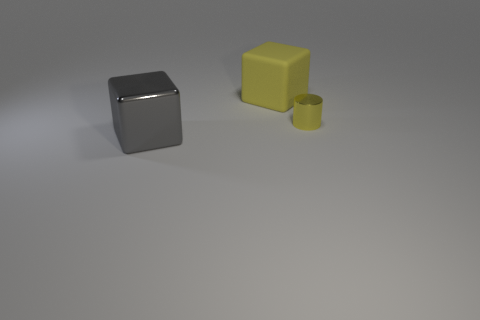Is the number of big blocks in front of the gray shiny object the same as the number of matte cubes that are in front of the yellow shiny object?
Provide a short and direct response. Yes. How many cylinders are the same color as the rubber cube?
Provide a succinct answer. 1. What is the material of the small cylinder that is the same color as the large matte block?
Offer a terse response. Metal. What number of matte objects are cylinders or purple cylinders?
Offer a terse response. 0. There is a large thing in front of the small thing; is it the same shape as the object behind the cylinder?
Provide a succinct answer. Yes. There is a tiny object; how many yellow blocks are behind it?
Give a very brief answer. 1. Are there any large yellow things made of the same material as the gray block?
Provide a succinct answer. No. What material is the object that is the same size as the gray cube?
Your answer should be very brief. Rubber. Is the material of the cylinder the same as the large gray thing?
Provide a succinct answer. Yes. How many things are yellow blocks or small shiny things?
Make the answer very short. 2. 